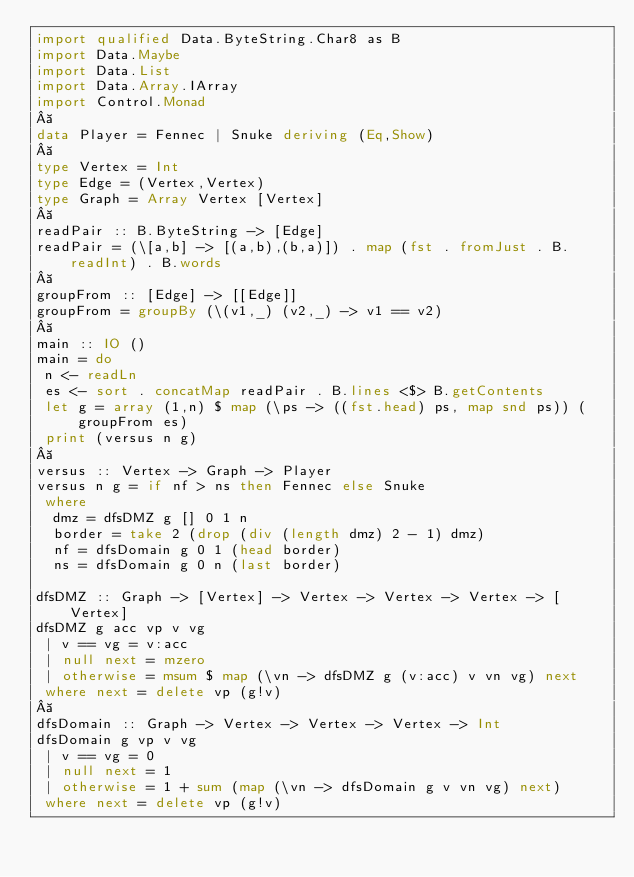Convert code to text. <code><loc_0><loc_0><loc_500><loc_500><_Haskell_>import qualified Data.ByteString.Char8 as B
import Data.Maybe
import Data.List
import Data.Array.IArray
import Control.Monad
 
data Player = Fennec | Snuke deriving (Eq,Show)
 
type Vertex = Int
type Edge = (Vertex,Vertex)
type Graph = Array Vertex [Vertex]
 
readPair :: B.ByteString -> [Edge]
readPair = (\[a,b] -> [(a,b),(b,a)]) . map (fst . fromJust . B.readInt) . B.words
 
groupFrom :: [Edge] -> [[Edge]]
groupFrom = groupBy (\(v1,_) (v2,_) -> v1 == v2)
 
main :: IO ()
main = do
 n <- readLn
 es <- sort . concatMap readPair . B.lines <$> B.getContents
 let g = array (1,n) $ map (\ps -> ((fst.head) ps, map snd ps)) (groupFrom es)
 print (versus n g)
 
versus :: Vertex -> Graph -> Player
versus n g = if nf > ns then Fennec else Snuke
 where
  dmz = dfsDMZ g [] 0 1 n
  border = take 2 (drop (div (length dmz) 2 - 1) dmz) 
  nf = dfsDomain g 0 1 (head border)
  ns = dfsDomain g 0 n (last border)

dfsDMZ :: Graph -> [Vertex] -> Vertex -> Vertex -> Vertex -> [Vertex]
dfsDMZ g acc vp v vg
 | v == vg = v:acc
 | null next = mzero
 | otherwise = msum $ map (\vn -> dfsDMZ g (v:acc) v vn vg) next
 where next = delete vp (g!v)
 
dfsDomain :: Graph -> Vertex -> Vertex -> Vertex -> Int
dfsDomain g vp v vg
 | v == vg = 0
 | null next = 1
 | otherwise = 1 + sum (map (\vn -> dfsDomain g v vn vg) next)
 where next = delete vp (g!v)</code> 